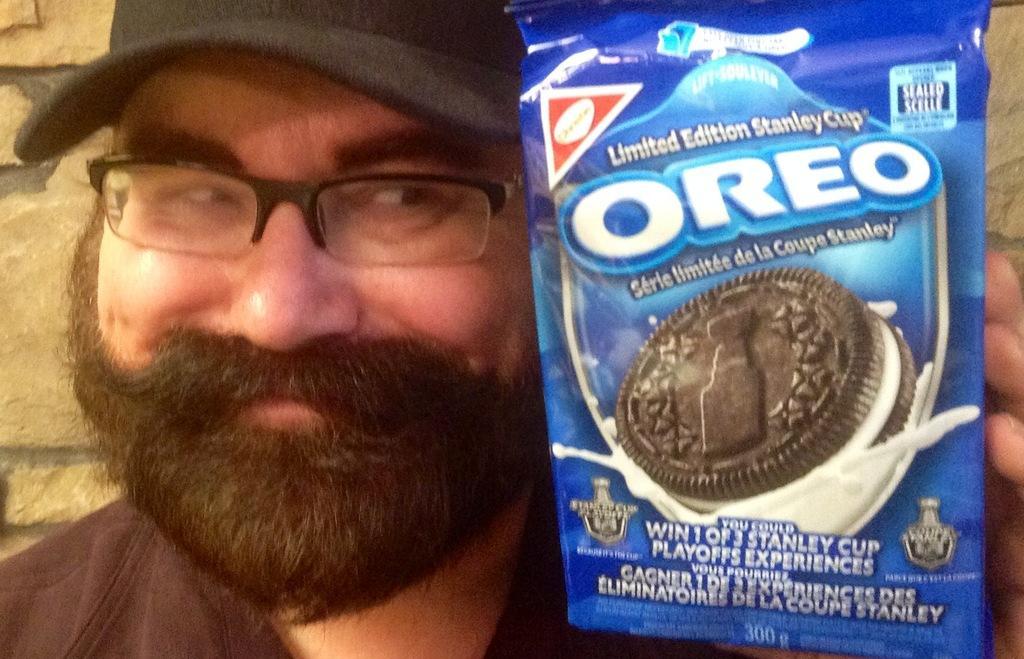In one or two sentences, can you explain what this image depicts? In this image we can see a person wearing the cap is holding a packet in his hand. In the background, we can see a wall. 